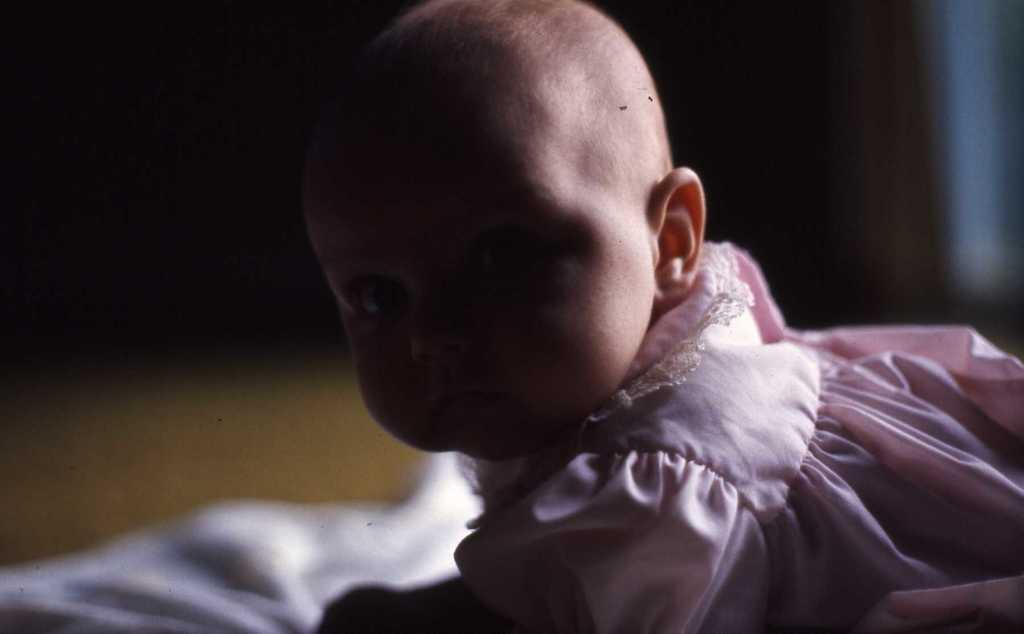What is the main subject of the image? The main subject of the image is a baby. What type of rock is the baby using as a toy in the image? There is no rock present in the image. What is the baby using to cover their face in the image? There is no object being used to cover the baby's face in the image. 